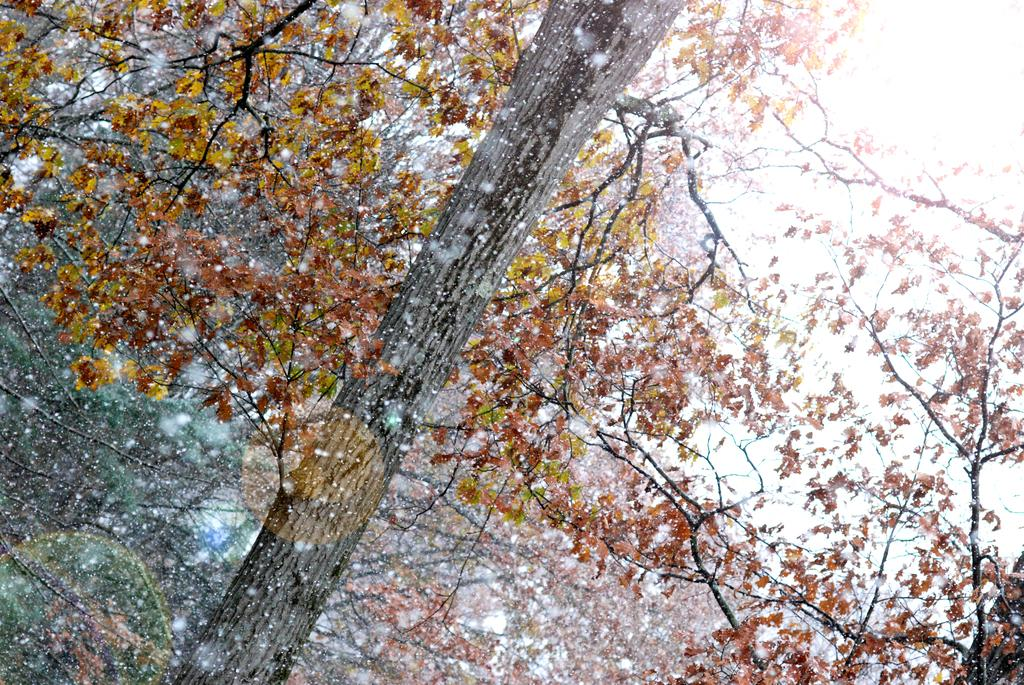What type of vegetation can be seen in the image? There are trees in the image. What part of the natural environment is visible in the image? The sky is visible in the image. What type of committee is meeting in the church depicted in the image? There is no church or committee present in the image; it only features trees and the sky. 